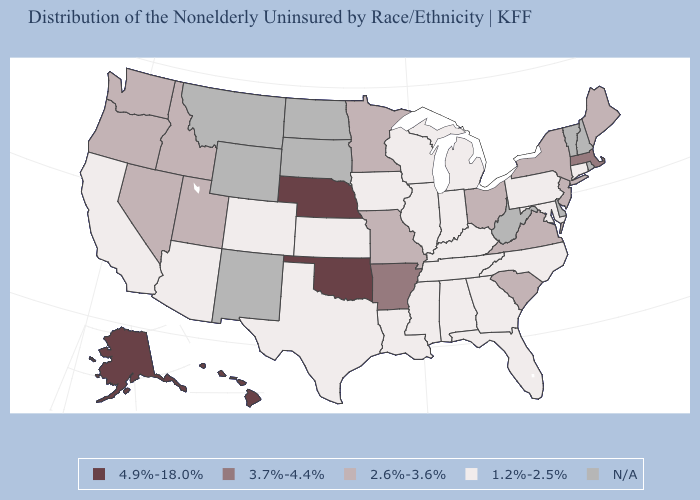Name the states that have a value in the range 3.7%-4.4%?
Write a very short answer. Arkansas, Massachusetts. What is the value of Delaware?
Be succinct. N/A. Which states have the highest value in the USA?
Short answer required. Alaska, Hawaii, Nebraska, Oklahoma. What is the lowest value in states that border Tennessee?
Short answer required. 1.2%-2.5%. Which states have the lowest value in the USA?
Keep it brief. Alabama, Arizona, California, Colorado, Connecticut, Florida, Georgia, Illinois, Indiana, Iowa, Kansas, Kentucky, Louisiana, Maryland, Michigan, Mississippi, North Carolina, Pennsylvania, Tennessee, Texas, Wisconsin. Name the states that have a value in the range 1.2%-2.5%?
Be succinct. Alabama, Arizona, California, Colorado, Connecticut, Florida, Georgia, Illinois, Indiana, Iowa, Kansas, Kentucky, Louisiana, Maryland, Michigan, Mississippi, North Carolina, Pennsylvania, Tennessee, Texas, Wisconsin. Among the states that border Wisconsin , does Illinois have the lowest value?
Keep it brief. Yes. What is the lowest value in states that border California?
Quick response, please. 1.2%-2.5%. What is the value of Kentucky?
Short answer required. 1.2%-2.5%. What is the highest value in states that border New York?
Give a very brief answer. 3.7%-4.4%. Does the map have missing data?
Be succinct. Yes. Name the states that have a value in the range 4.9%-18.0%?
Be succinct. Alaska, Hawaii, Nebraska, Oklahoma. What is the value of Montana?
Give a very brief answer. N/A. Among the states that border North Carolina , which have the highest value?
Quick response, please. South Carolina, Virginia. 